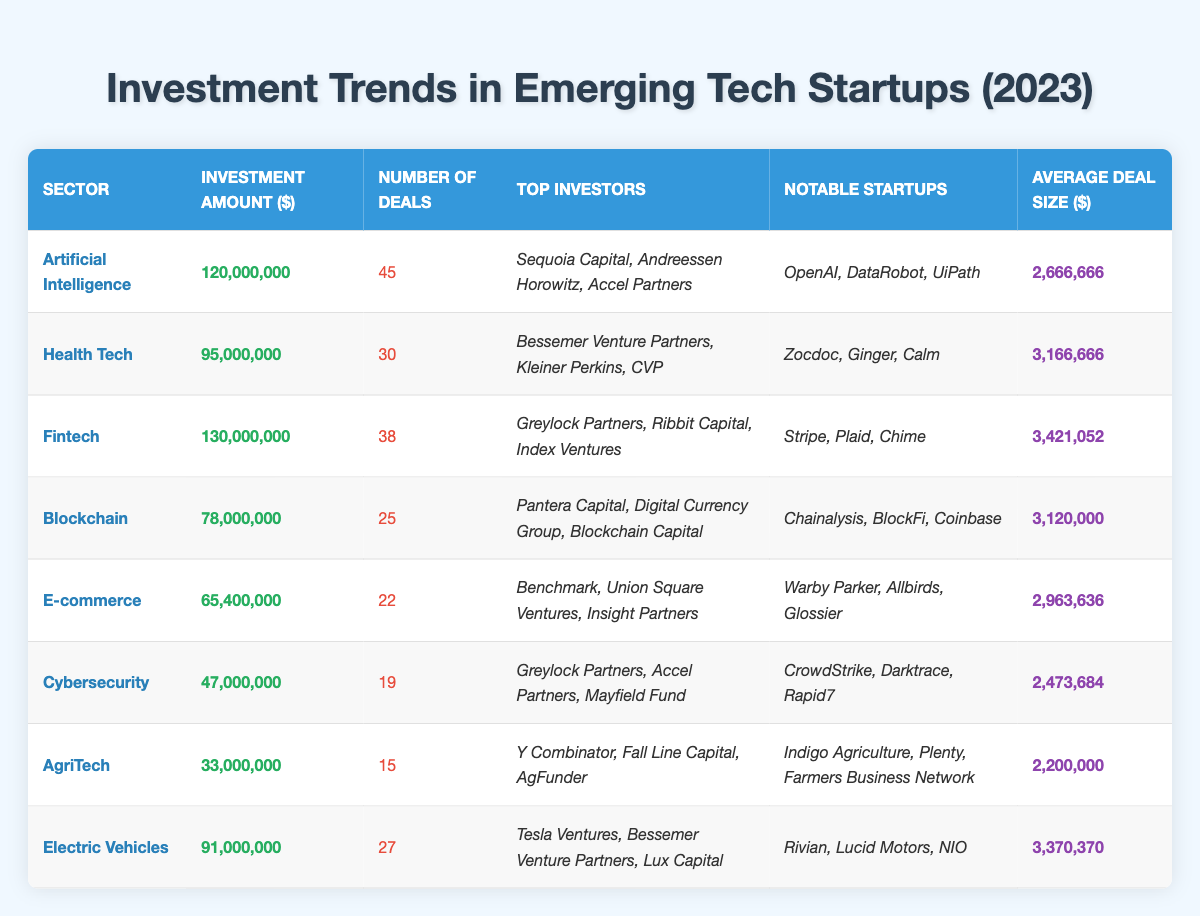What is the total investment amount across all sectors? To find the total investment amount, we sum the investment amounts in each sector: 120,000,000 + 95,000,000 + 130,000,000 + 78,000,000 + 65,400,000 + 47,000,000 + 33,000,000 + 91,000,000 = 759,400,000.
Answer: 759,400,000 Which sector has the highest number of deals? By examining the number of deals for each sector, we see that Artificial Intelligence has 45 deals, which is more than any other sector.
Answer: Artificial Intelligence What is the average deal size for the Health Tech sector? The average deal size for Health Tech is directly provided in the table as 3,166,666.
Answer: 3,166,666 Which sector has the lowest investment amount and what is that amount? By reviewing the investment amounts, AgriTech has the lowest investment at 33,000,000.
Answer: AgriTech, 33,000,000 How many sectors have investment amounts over 80 million? The sectors with investment amounts over 80 million are Artificial Intelligence (120,000,000), Fintech (130,000,000), and Electric Vehicles (91,000,000), making a total of 3 sectors.
Answer: 3 What is the total number of deals in the Cybersecurity and E-commerce sectors combined? The number of deals in Cybersecurity is 19 and in E-commerce is 22. Adding these together gives 19 + 22 = 41.
Answer: 41 Is the average deal size for Fintech greater than that of Health Tech? The average deal size for Fintech is 3,421,052 and for Health Tech it is 3,166,666. Since 3,421,052 is greater than 3,166,666, the statement is true.
Answer: Yes What percentage of the total investment does the Blockchain sector represent? The Blockchain sector has an investment amount of 78,000,000. To find the percentage, we divide 78,000,000 by the total investment (759,400,000) and multiply by 100: (78,000,000 / 759,400,000) * 100 ≈ 10.27%.
Answer: 10.27% Which investor appears in both the Fintech and Cybersecurity sectors? Greylock Partners is listed as a top investor in both the Fintech and Cybersecurity sectors.
Answer: Greylock Partners What is the average investment amount per deal in the Electric Vehicles sector? The Electric Vehicles sector has an investment amount of 91,000,000 and 27 deals. Dividing the investment amount by the number of deals gives the average: 91,000,000 / 27 ≈ 3,370,370.
Answer: 3,370,370 